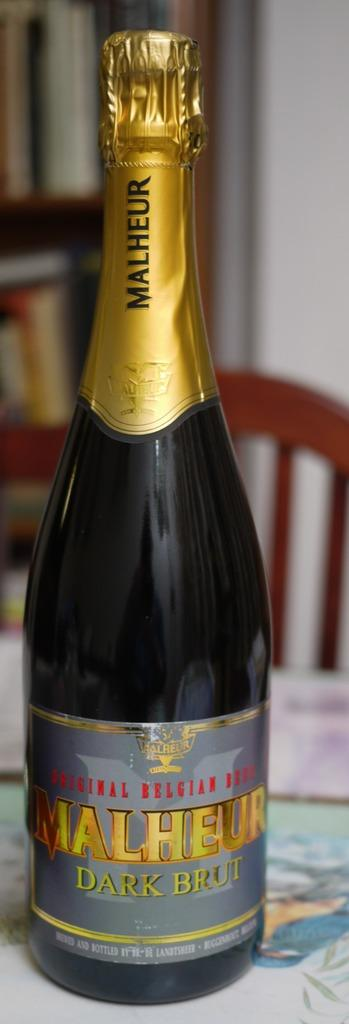<image>
Write a terse but informative summary of the picture. A bottle of Malheur Dark Brut wine sitting on a tabletop. 